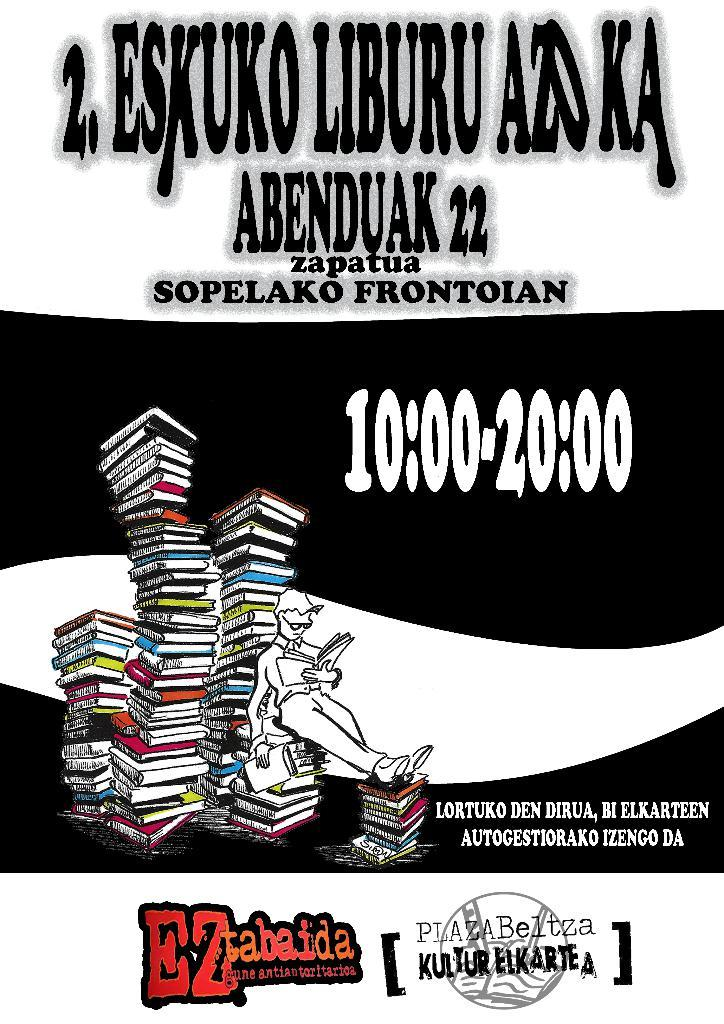Provide a one-sentence caption for the provided image. An ad for EZ tabaida from 10:00 to 20:00. 